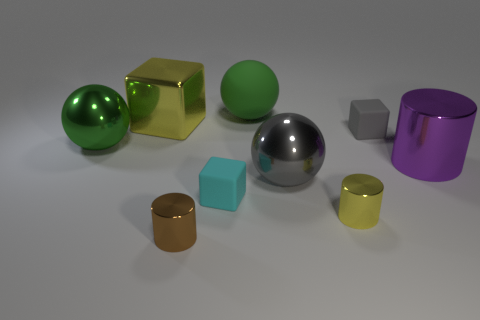Add 1 large blocks. How many objects exist? 10 Subtract all cubes. How many objects are left? 6 Add 5 small things. How many small things are left? 9 Add 9 gray matte cylinders. How many gray matte cylinders exist? 9 Subtract 0 blue spheres. How many objects are left? 9 Subtract all cyan metallic objects. Subtract all large rubber spheres. How many objects are left? 8 